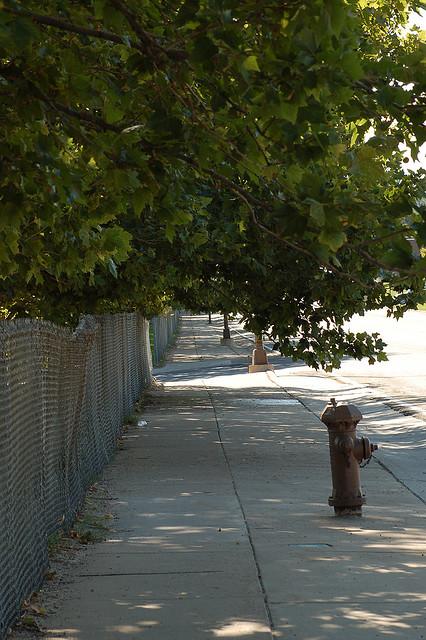Are there flowers in the photo? No, there are no flowers visible in the photo, which focuses more on the tree-lined sidewalk and the fire hydrant. 